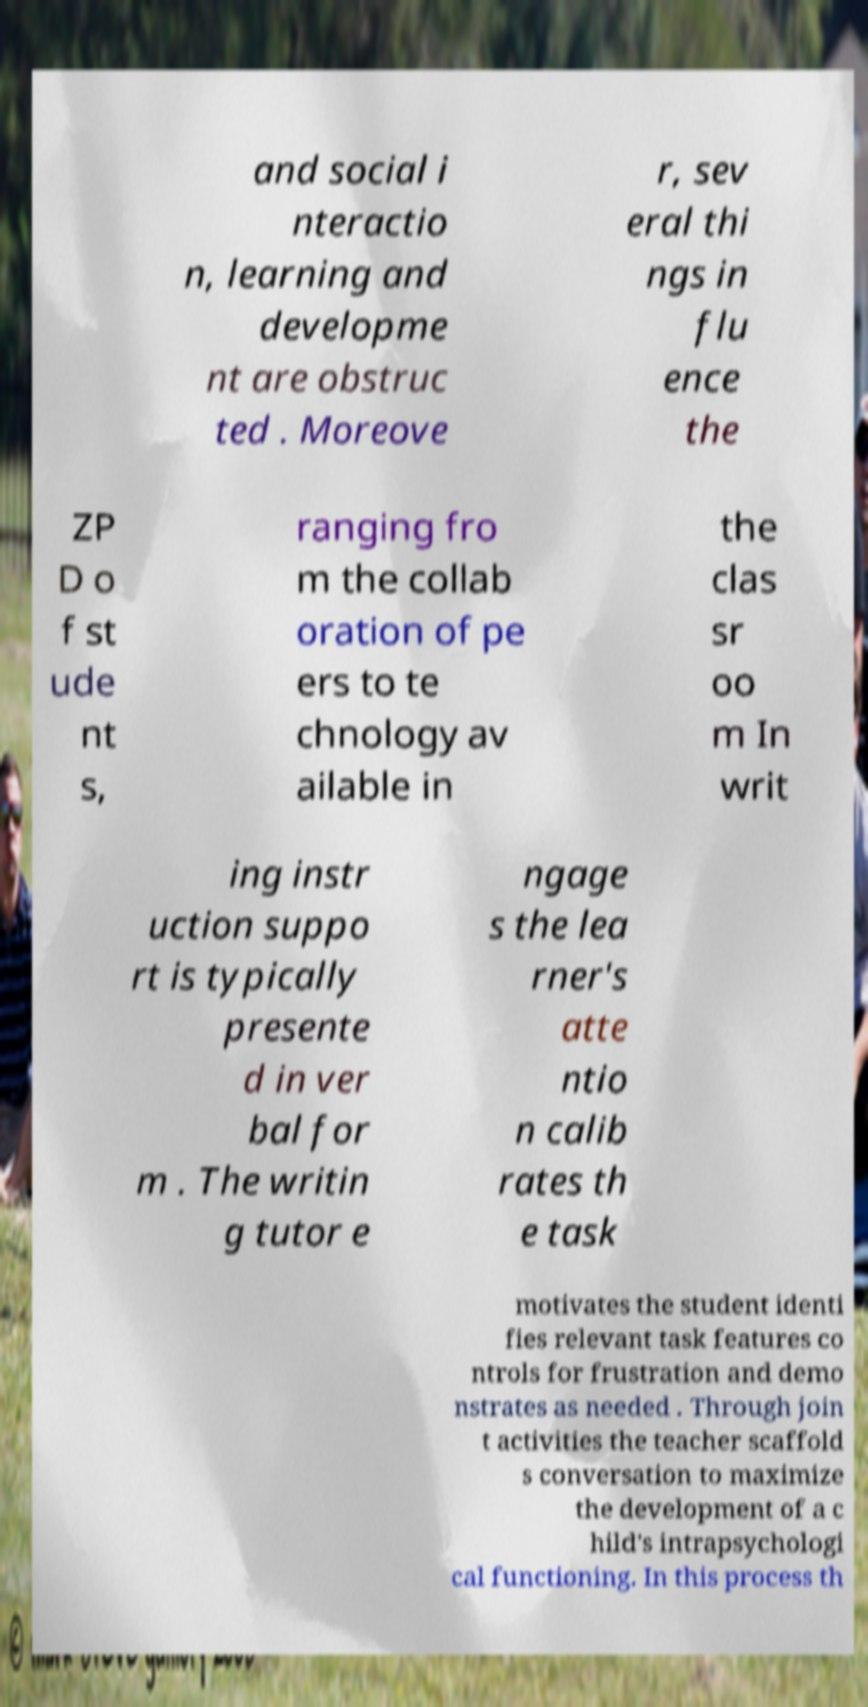Can you accurately transcribe the text from the provided image for me? and social i nteractio n, learning and developme nt are obstruc ted . Moreove r, sev eral thi ngs in flu ence the ZP D o f st ude nt s, ranging fro m the collab oration of pe ers to te chnology av ailable in the clas sr oo m In writ ing instr uction suppo rt is typically presente d in ver bal for m . The writin g tutor e ngage s the lea rner's atte ntio n calib rates th e task motivates the student identi fies relevant task features co ntrols for frustration and demo nstrates as needed . Through join t activities the teacher scaffold s conversation to maximize the development of a c hild's intrapsychologi cal functioning. In this process th 